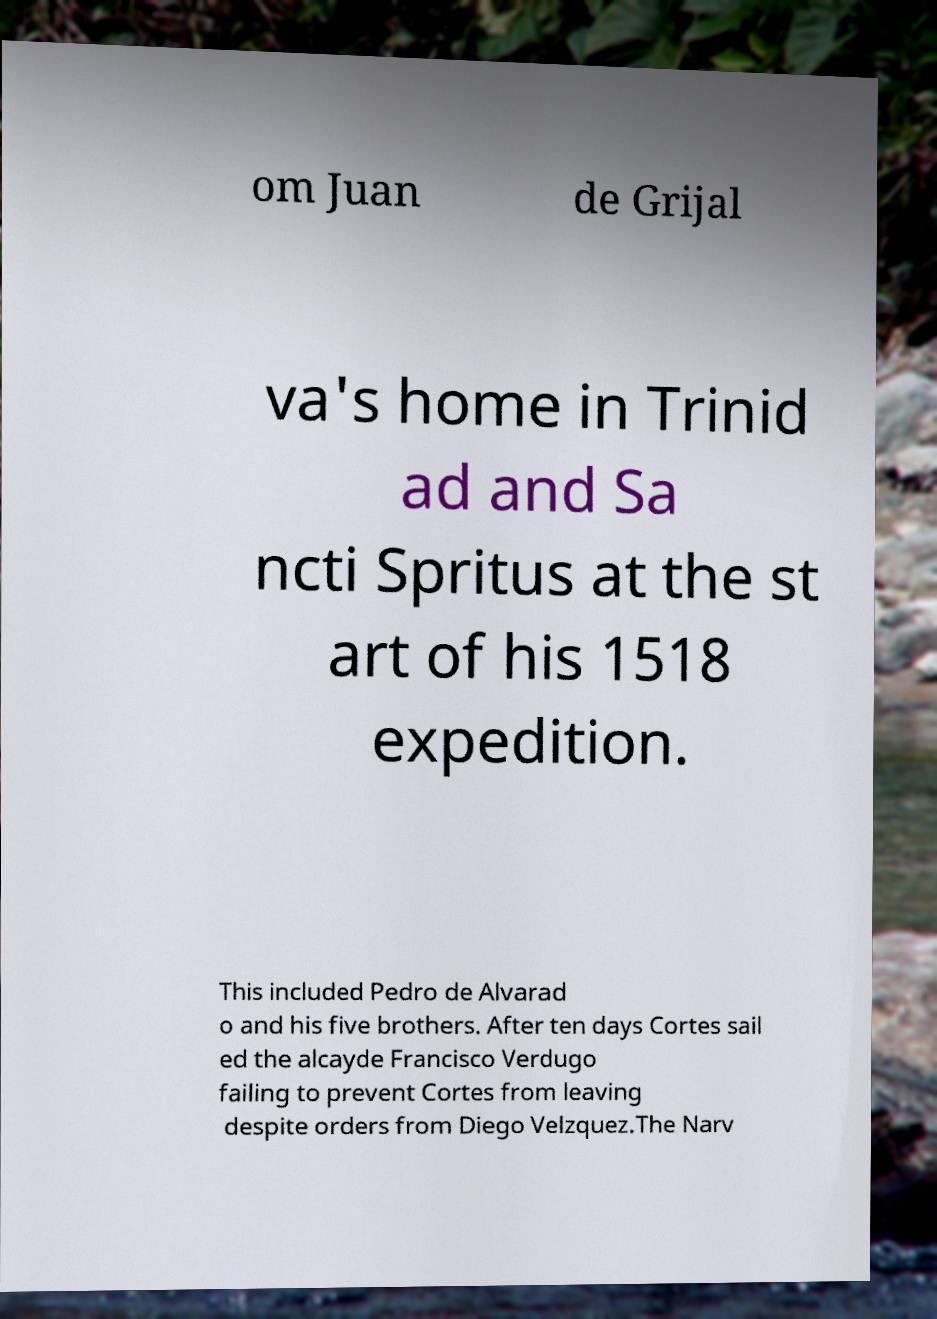Please identify and transcribe the text found in this image. om Juan de Grijal va's home in Trinid ad and Sa ncti Spritus at the st art of his 1518 expedition. This included Pedro de Alvarad o and his five brothers. After ten days Cortes sail ed the alcayde Francisco Verdugo failing to prevent Cortes from leaving despite orders from Diego Velzquez.The Narv 